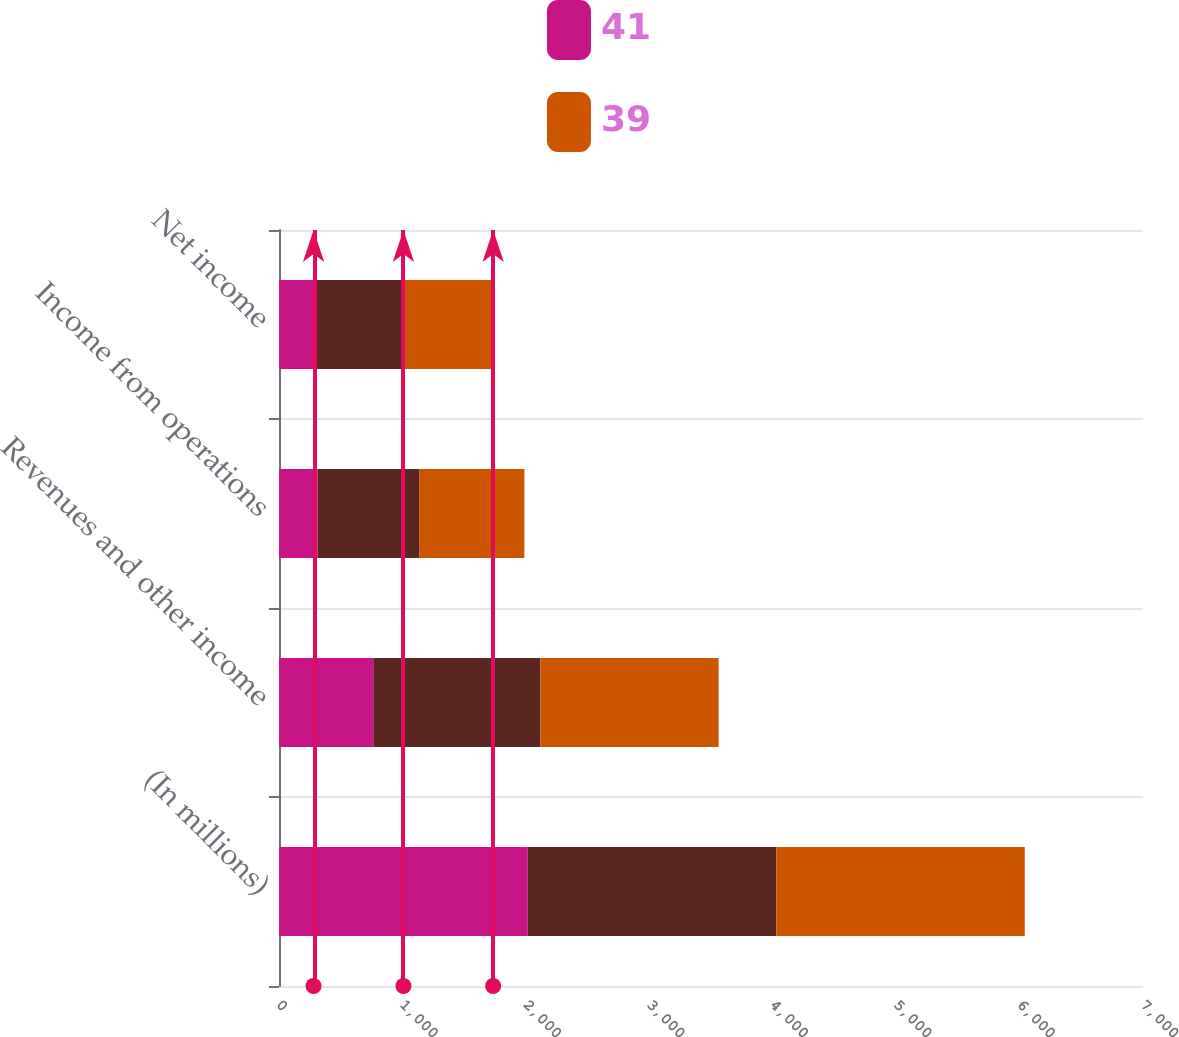Convert chart to OTSL. <chart><loc_0><loc_0><loc_500><loc_500><stacked_bar_chart><ecel><fcel>(In millions)<fcel>Revenues and other income<fcel>Income from operations<fcel>Net income<nl><fcel>41<fcel>2015<fcel>769<fcel>313<fcel>280<nl><fcel>nan<fcel>2014<fcel>1349<fcel>826<fcel>728<nl><fcel>39<fcel>2013<fcel>1444<fcel>849<fcel>727<nl></chart> 